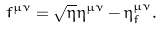Convert formula to latex. <formula><loc_0><loc_0><loc_500><loc_500>f ^ { \mu \nu } = \sqrt { \eta } \eta ^ { \mu \nu } - \eta _ { f } ^ { \mu \nu } .</formula> 